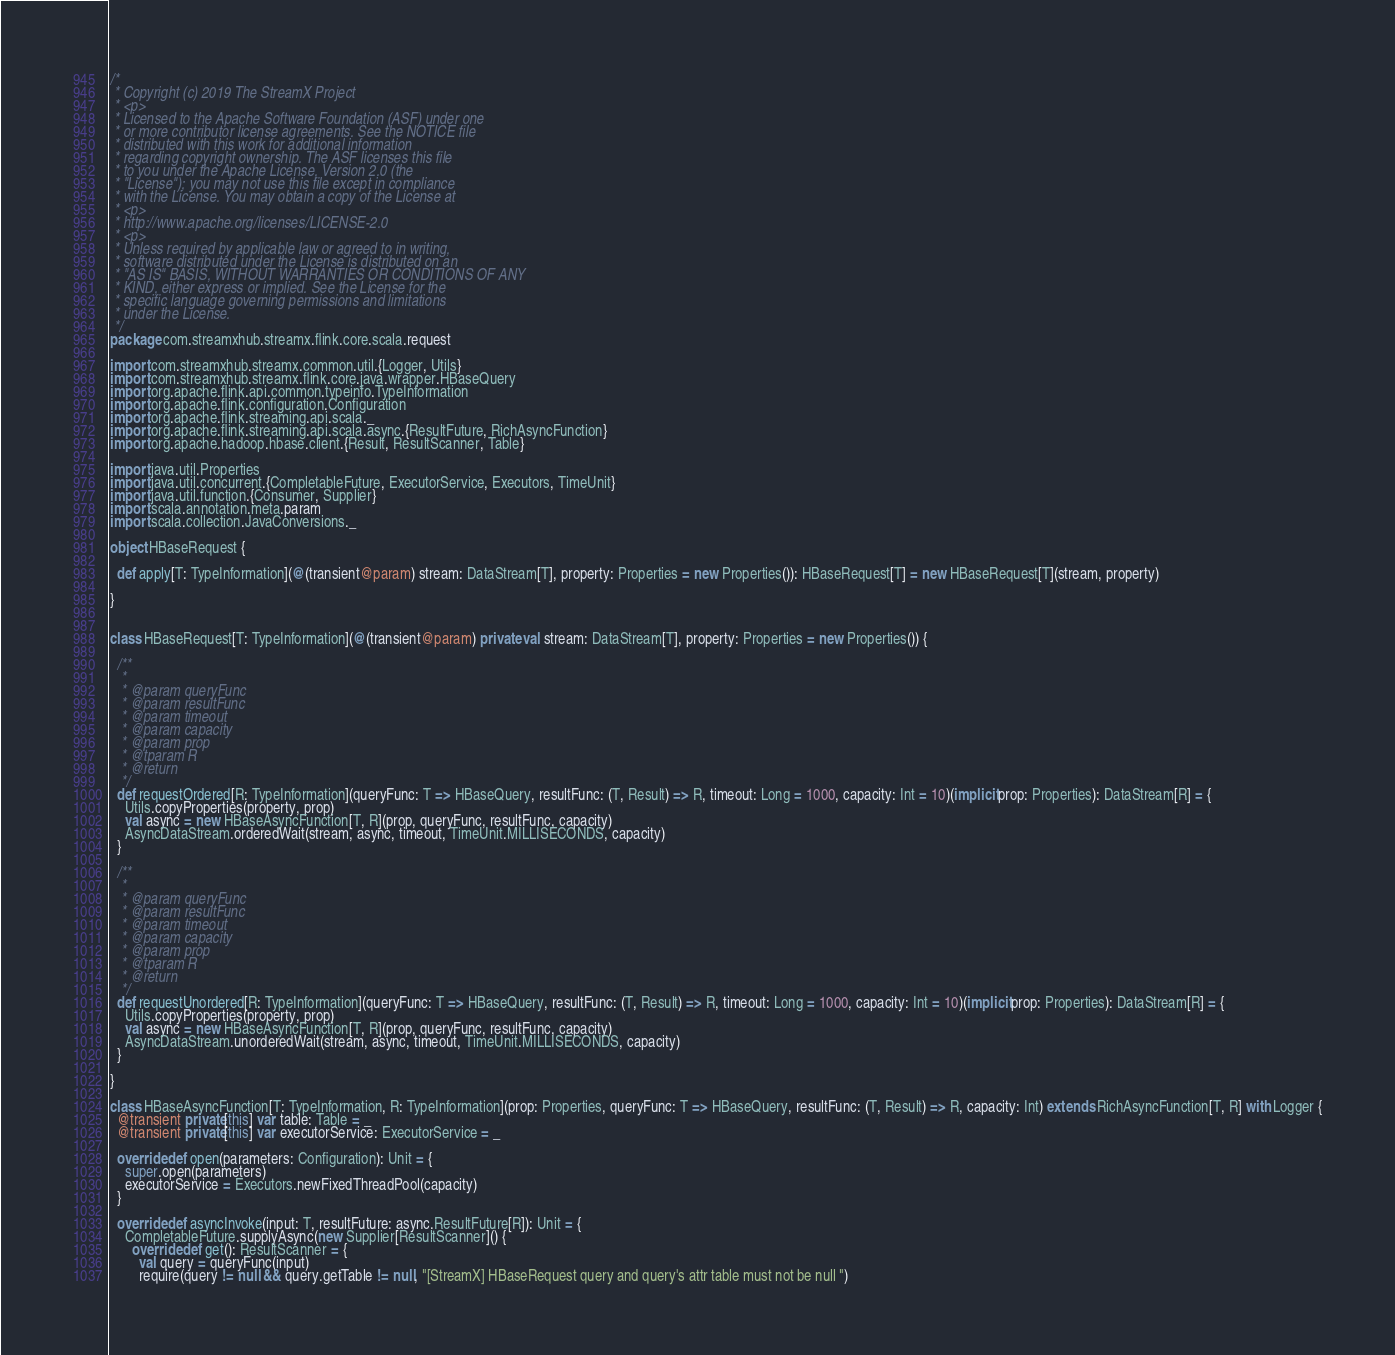Convert code to text. <code><loc_0><loc_0><loc_500><loc_500><_Scala_>/*
 * Copyright (c) 2019 The StreamX Project
 * <p>
 * Licensed to the Apache Software Foundation (ASF) under one
 * or more contributor license agreements. See the NOTICE file
 * distributed with this work for additional information
 * regarding copyright ownership. The ASF licenses this file
 * to you under the Apache License, Version 2.0 (the
 * "License"); you may not use this file except in compliance
 * with the License. You may obtain a copy of the License at
 * <p>
 * http://www.apache.org/licenses/LICENSE-2.0
 * <p>
 * Unless required by applicable law or agreed to in writing,
 * software distributed under the License is distributed on an
 * "AS IS" BASIS, WITHOUT WARRANTIES OR CONDITIONS OF ANY
 * KIND, either express or implied. See the License for the
 * specific language governing permissions and limitations
 * under the License.
 */
package com.streamxhub.streamx.flink.core.scala.request

import com.streamxhub.streamx.common.util.{Logger, Utils}
import com.streamxhub.streamx.flink.core.java.wrapper.HBaseQuery
import org.apache.flink.api.common.typeinfo.TypeInformation
import org.apache.flink.configuration.Configuration
import org.apache.flink.streaming.api.scala._
import org.apache.flink.streaming.api.scala.async.{ResultFuture, RichAsyncFunction}
import org.apache.hadoop.hbase.client.{Result, ResultScanner, Table}

import java.util.Properties
import java.util.concurrent.{CompletableFuture, ExecutorService, Executors, TimeUnit}
import java.util.function.{Consumer, Supplier}
import scala.annotation.meta.param
import scala.collection.JavaConversions._

object HBaseRequest {

  def apply[T: TypeInformation](@(transient@param) stream: DataStream[T], property: Properties = new Properties()): HBaseRequest[T] = new HBaseRequest[T](stream, property)

}


class HBaseRequest[T: TypeInformation](@(transient@param) private val stream: DataStream[T], property: Properties = new Properties()) {

  /**
   *
   * @param queryFunc
   * @param resultFunc
   * @param timeout
   * @param capacity
   * @param prop
   * @tparam R
   * @return
   */
  def requestOrdered[R: TypeInformation](queryFunc: T => HBaseQuery, resultFunc: (T, Result) => R, timeout: Long = 1000, capacity: Int = 10)(implicit prop: Properties): DataStream[R] = {
    Utils.copyProperties(property, prop)
    val async = new HBaseAsyncFunction[T, R](prop, queryFunc, resultFunc, capacity)
    AsyncDataStream.orderedWait(stream, async, timeout, TimeUnit.MILLISECONDS, capacity)
  }

  /**
   *
   * @param queryFunc
   * @param resultFunc
   * @param timeout
   * @param capacity
   * @param prop
   * @tparam R
   * @return
   */
  def requestUnordered[R: TypeInformation](queryFunc: T => HBaseQuery, resultFunc: (T, Result) => R, timeout: Long = 1000, capacity: Int = 10)(implicit prop: Properties): DataStream[R] = {
    Utils.copyProperties(property, prop)
    val async = new HBaseAsyncFunction[T, R](prop, queryFunc, resultFunc, capacity)
    AsyncDataStream.unorderedWait(stream, async, timeout, TimeUnit.MILLISECONDS, capacity)
  }

}

class HBaseAsyncFunction[T: TypeInformation, R: TypeInformation](prop: Properties, queryFunc: T => HBaseQuery, resultFunc: (T, Result) => R, capacity: Int) extends RichAsyncFunction[T, R] with Logger {
  @transient private[this] var table: Table = _
  @transient private[this] var executorService: ExecutorService = _

  override def open(parameters: Configuration): Unit = {
    super.open(parameters)
    executorService = Executors.newFixedThreadPool(capacity)
  }

  override def asyncInvoke(input: T, resultFuture: async.ResultFuture[R]): Unit = {
    CompletableFuture.supplyAsync(new Supplier[ResultScanner]() {
      override def get(): ResultScanner = {
        val query = queryFunc(input)
        require(query != null && query.getTable != null, "[StreamX] HBaseRequest query and query's attr table must not be null ")</code> 